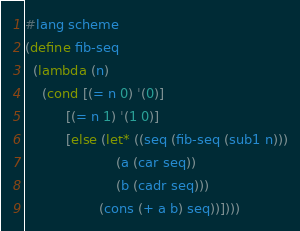<code> <loc_0><loc_0><loc_500><loc_500><_Scheme_>#lang scheme
(define fib-seq
  (lambda (n)
    (cond [(= n 0) '(0)]
          [(= n 1) '(1 0)]
          [else (let* ((seq (fib-seq (sub1 n)))
                      (a (car seq))
                      (b (cadr seq)))
                  (cons (+ a b) seq))])))</code> 